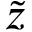Convert formula to latex. <formula><loc_0><loc_0><loc_500><loc_500>\tilde { z }</formula> 